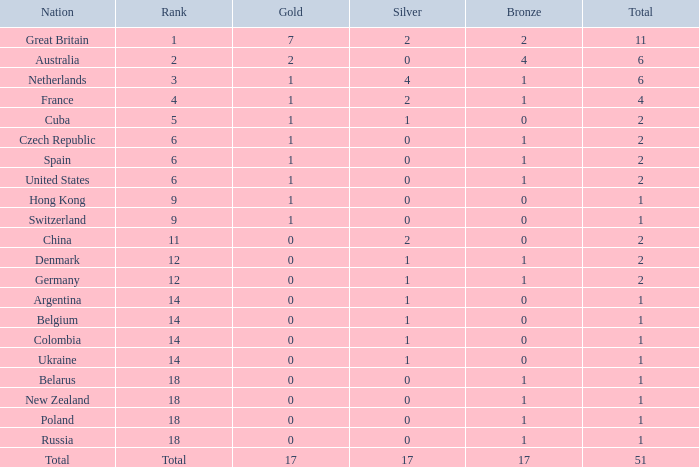Tell me the rank for bronze less than 17 and gold less than 1 11.0. 